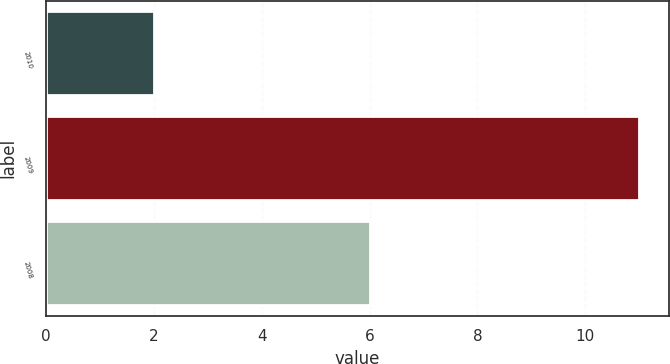<chart> <loc_0><loc_0><loc_500><loc_500><bar_chart><fcel>2010<fcel>2009<fcel>2008<nl><fcel>2<fcel>11<fcel>6<nl></chart> 